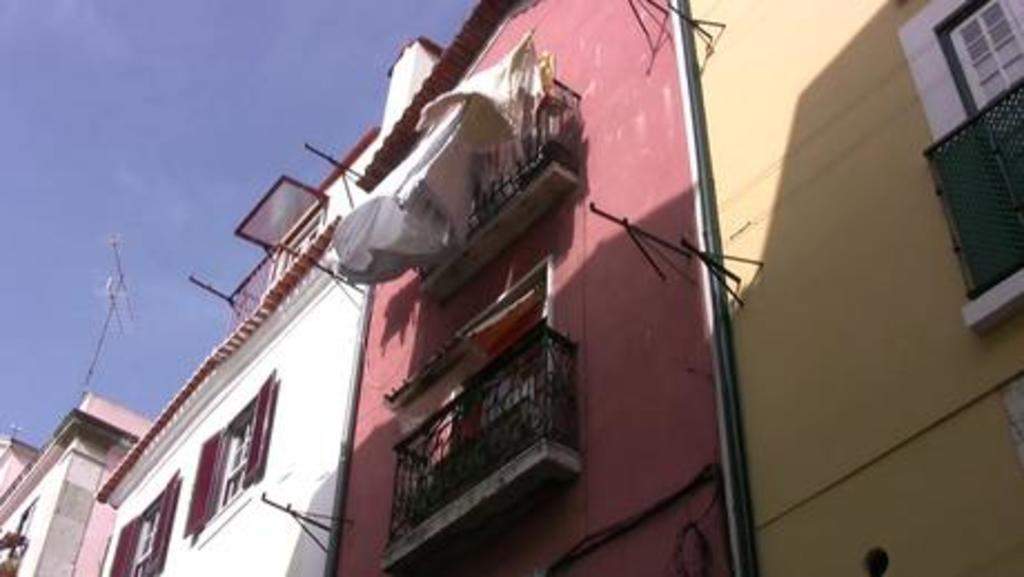Where was the image taken? The image was clicked outside. What can be seen in the foreground of the image? There are buildings in the foreground of the image. What features do the buildings have? The buildings have windows, deck rails, and walls. What material is visible in the image? There are metal rods visible in the image. What is visible in the background of the image? The sky is visible in the image. Can you see any beds in the image? There are no beds visible in the image. Is there a fight happening in the image? There is no fight depicted in the image. 